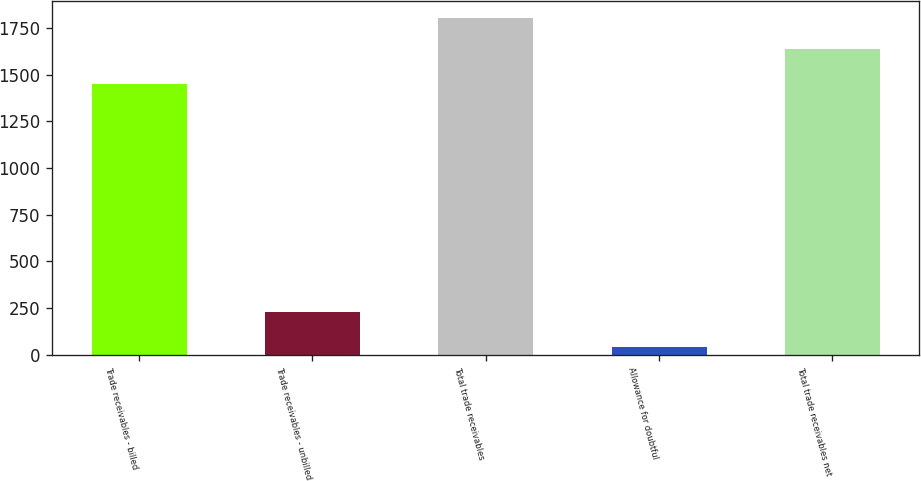<chart> <loc_0><loc_0><loc_500><loc_500><bar_chart><fcel>Trade receivables - billed<fcel>Trade receivables - unbilled<fcel>Total trade receivables<fcel>Allowance for doubtful<fcel>Total trade receivables net<nl><fcel>1452<fcel>228<fcel>1802.9<fcel>41<fcel>1639<nl></chart> 